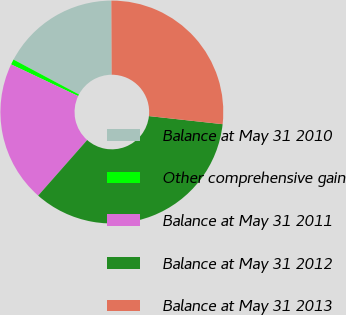Convert chart. <chart><loc_0><loc_0><loc_500><loc_500><pie_chart><fcel>Balance at May 31 2010<fcel>Other comprehensive gain<fcel>Balance at May 31 2011<fcel>Balance at May 31 2012<fcel>Balance at May 31 2013<nl><fcel>17.13%<fcel>0.77%<fcel>20.53%<fcel>34.76%<fcel>26.81%<nl></chart> 